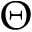Convert formula to latex. <formula><loc_0><loc_0><loc_500><loc_500>\Theta</formula> 